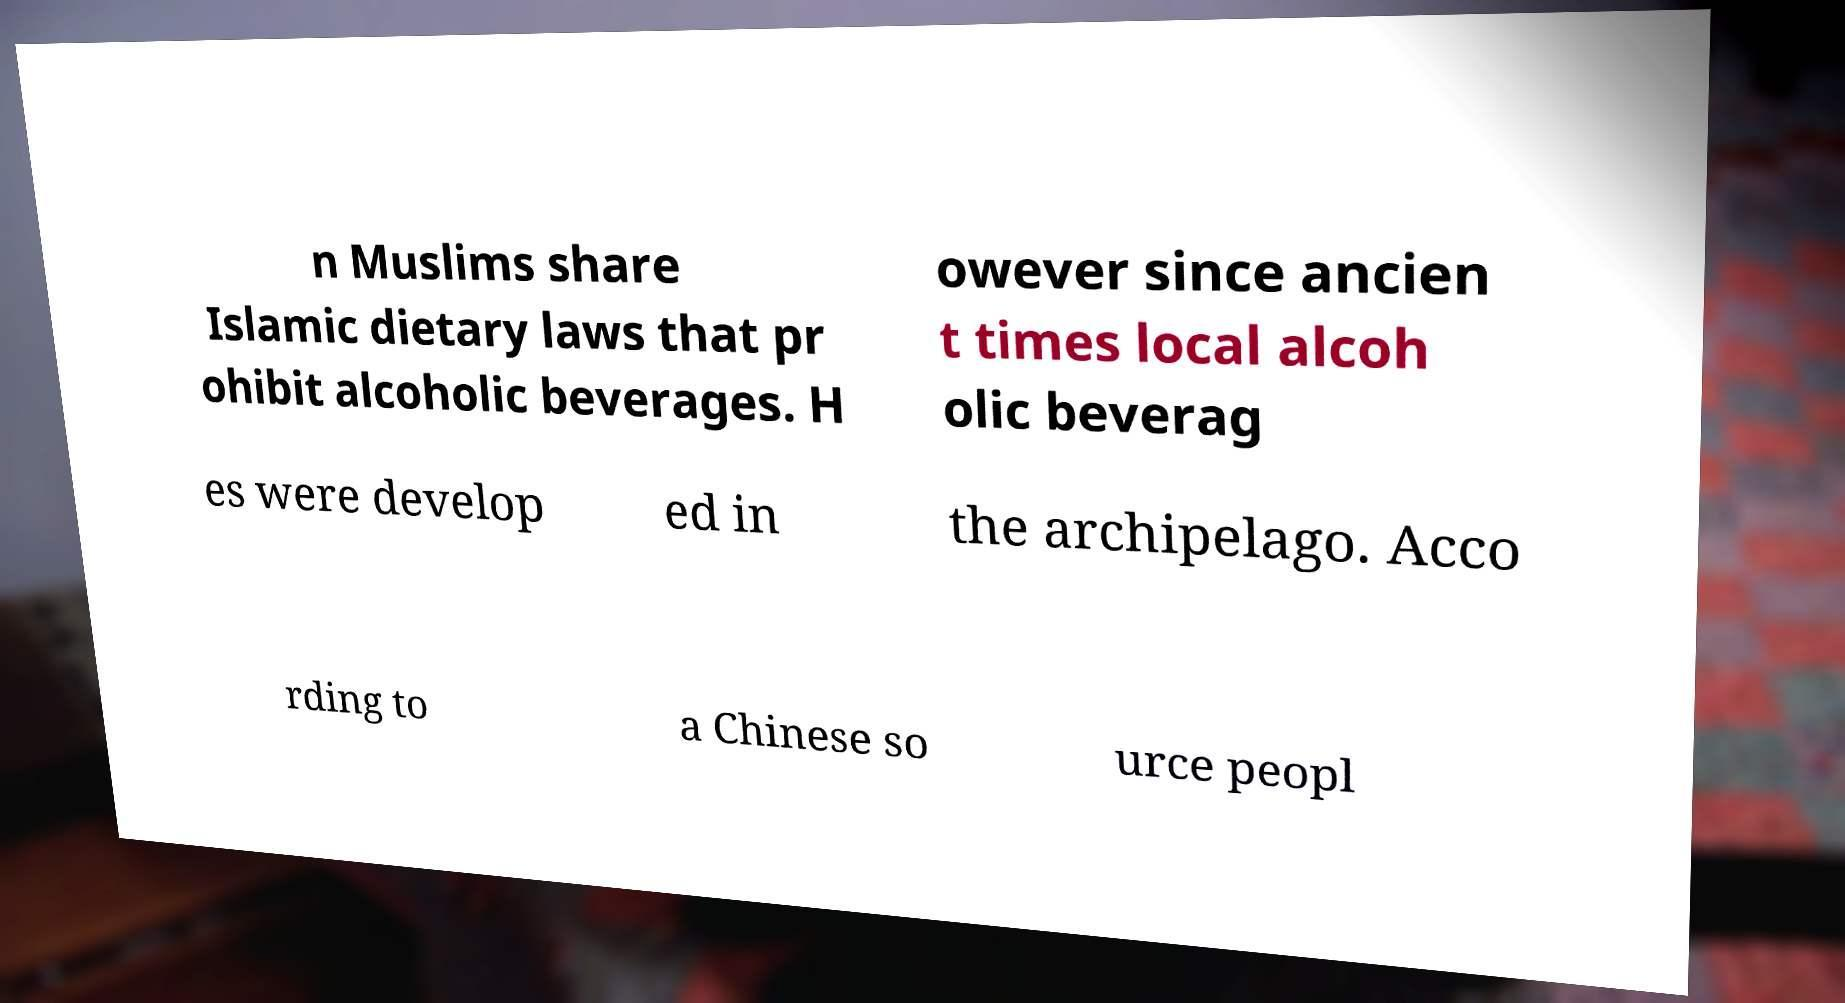Could you assist in decoding the text presented in this image and type it out clearly? n Muslims share Islamic dietary laws that pr ohibit alcoholic beverages. H owever since ancien t times local alcoh olic beverag es were develop ed in the archipelago. Acco rding to a Chinese so urce peopl 